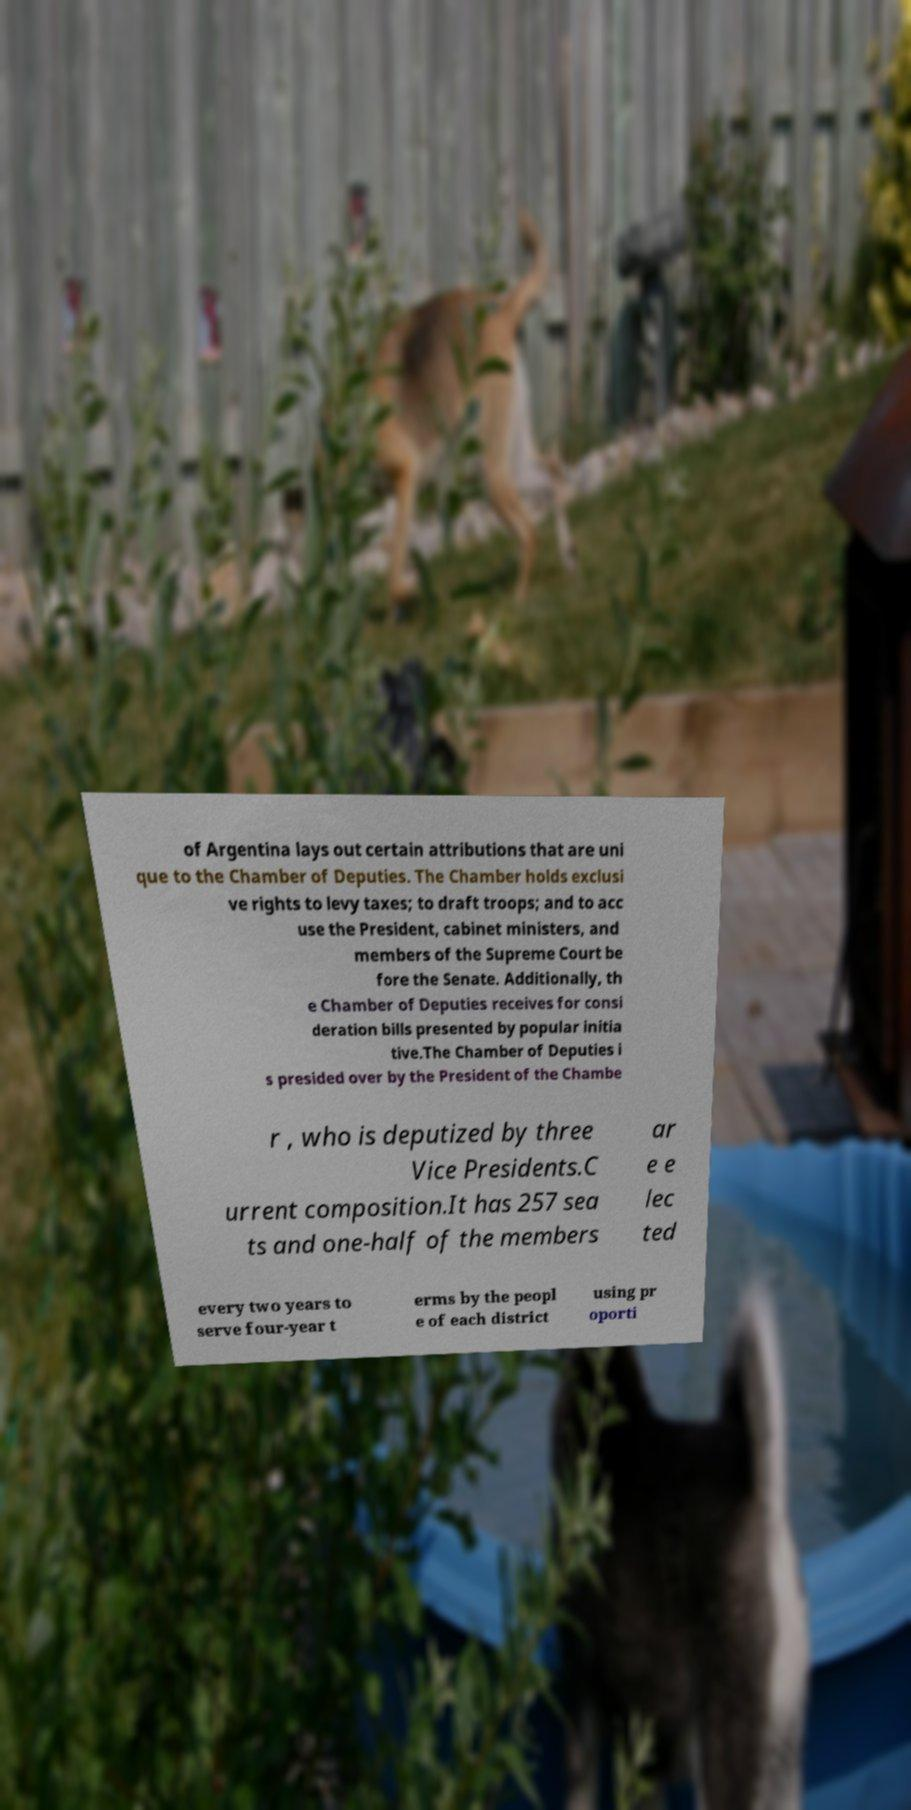Could you assist in decoding the text presented in this image and type it out clearly? of Argentina lays out certain attributions that are uni que to the Chamber of Deputies. The Chamber holds exclusi ve rights to levy taxes; to draft troops; and to acc use the President, cabinet ministers, and members of the Supreme Court be fore the Senate. Additionally, th e Chamber of Deputies receives for consi deration bills presented by popular initia tive.The Chamber of Deputies i s presided over by the President of the Chambe r , who is deputized by three Vice Presidents.C urrent composition.It has 257 sea ts and one-half of the members ar e e lec ted every two years to serve four-year t erms by the peopl e of each district using pr oporti 